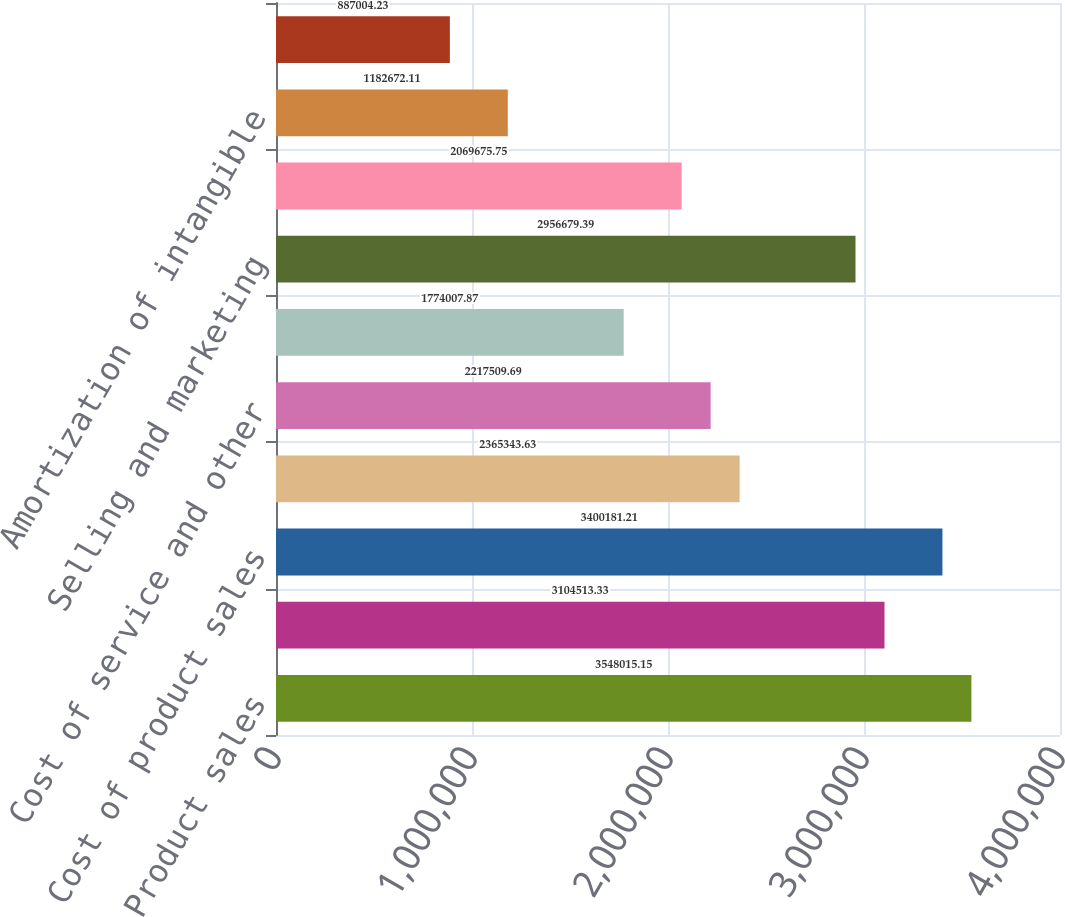Convert chart. <chart><loc_0><loc_0><loc_500><loc_500><bar_chart><fcel>Product sales<fcel>Service and other revenues<fcel>Cost of product sales<fcel>Cost of product<fcel>Cost of service and other<fcel>Research and development<fcel>Selling and marketing<fcel>General and administrative<fcel>Amortization of intangible<fcel>Contingent<nl><fcel>3.54802e+06<fcel>3.10451e+06<fcel>3.40018e+06<fcel>2.36534e+06<fcel>2.21751e+06<fcel>1.77401e+06<fcel>2.95668e+06<fcel>2.06968e+06<fcel>1.18267e+06<fcel>887004<nl></chart> 